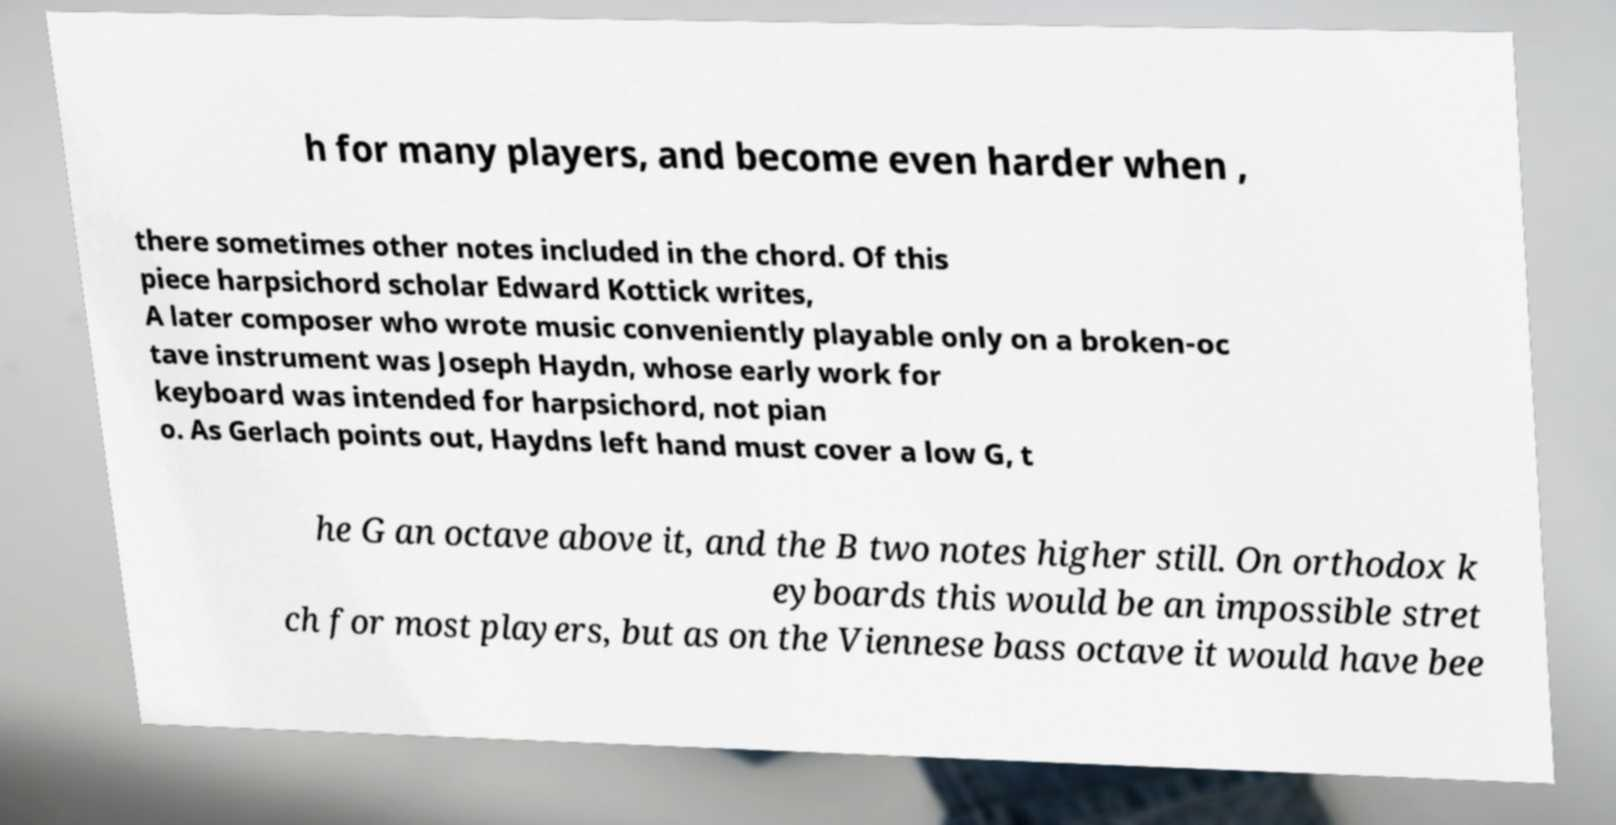What messages or text are displayed in this image? I need them in a readable, typed format. h for many players, and become even harder when , there sometimes other notes included in the chord. Of this piece harpsichord scholar Edward Kottick writes, A later composer who wrote music conveniently playable only on a broken-oc tave instrument was Joseph Haydn, whose early work for keyboard was intended for harpsichord, not pian o. As Gerlach points out, Haydns left hand must cover a low G, t he G an octave above it, and the B two notes higher still. On orthodox k eyboards this would be an impossible stret ch for most players, but as on the Viennese bass octave it would have bee 